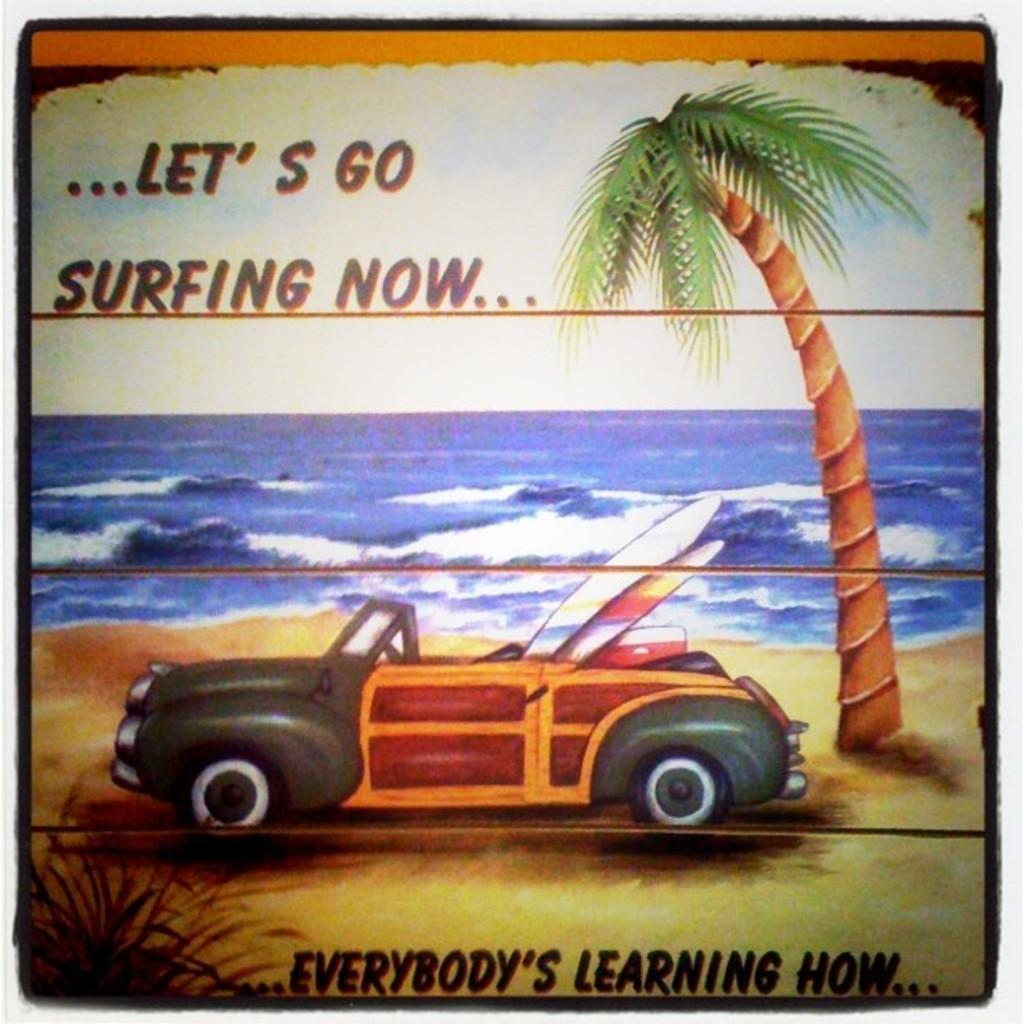What type of content is present in the image? The image contains text. What natural elements can be seen in the image? There are leaves and a tree in the image. What type of landscape is visible in the image? There is: There is an ocean in the image. What man-made object is present in the image? There is a car in the image. Where is the record player located in the image? There is no record player present in the image. What type of spider web can be seen on the tree in the image? There is no spider web, or cobweb, present on the tree in the image. 